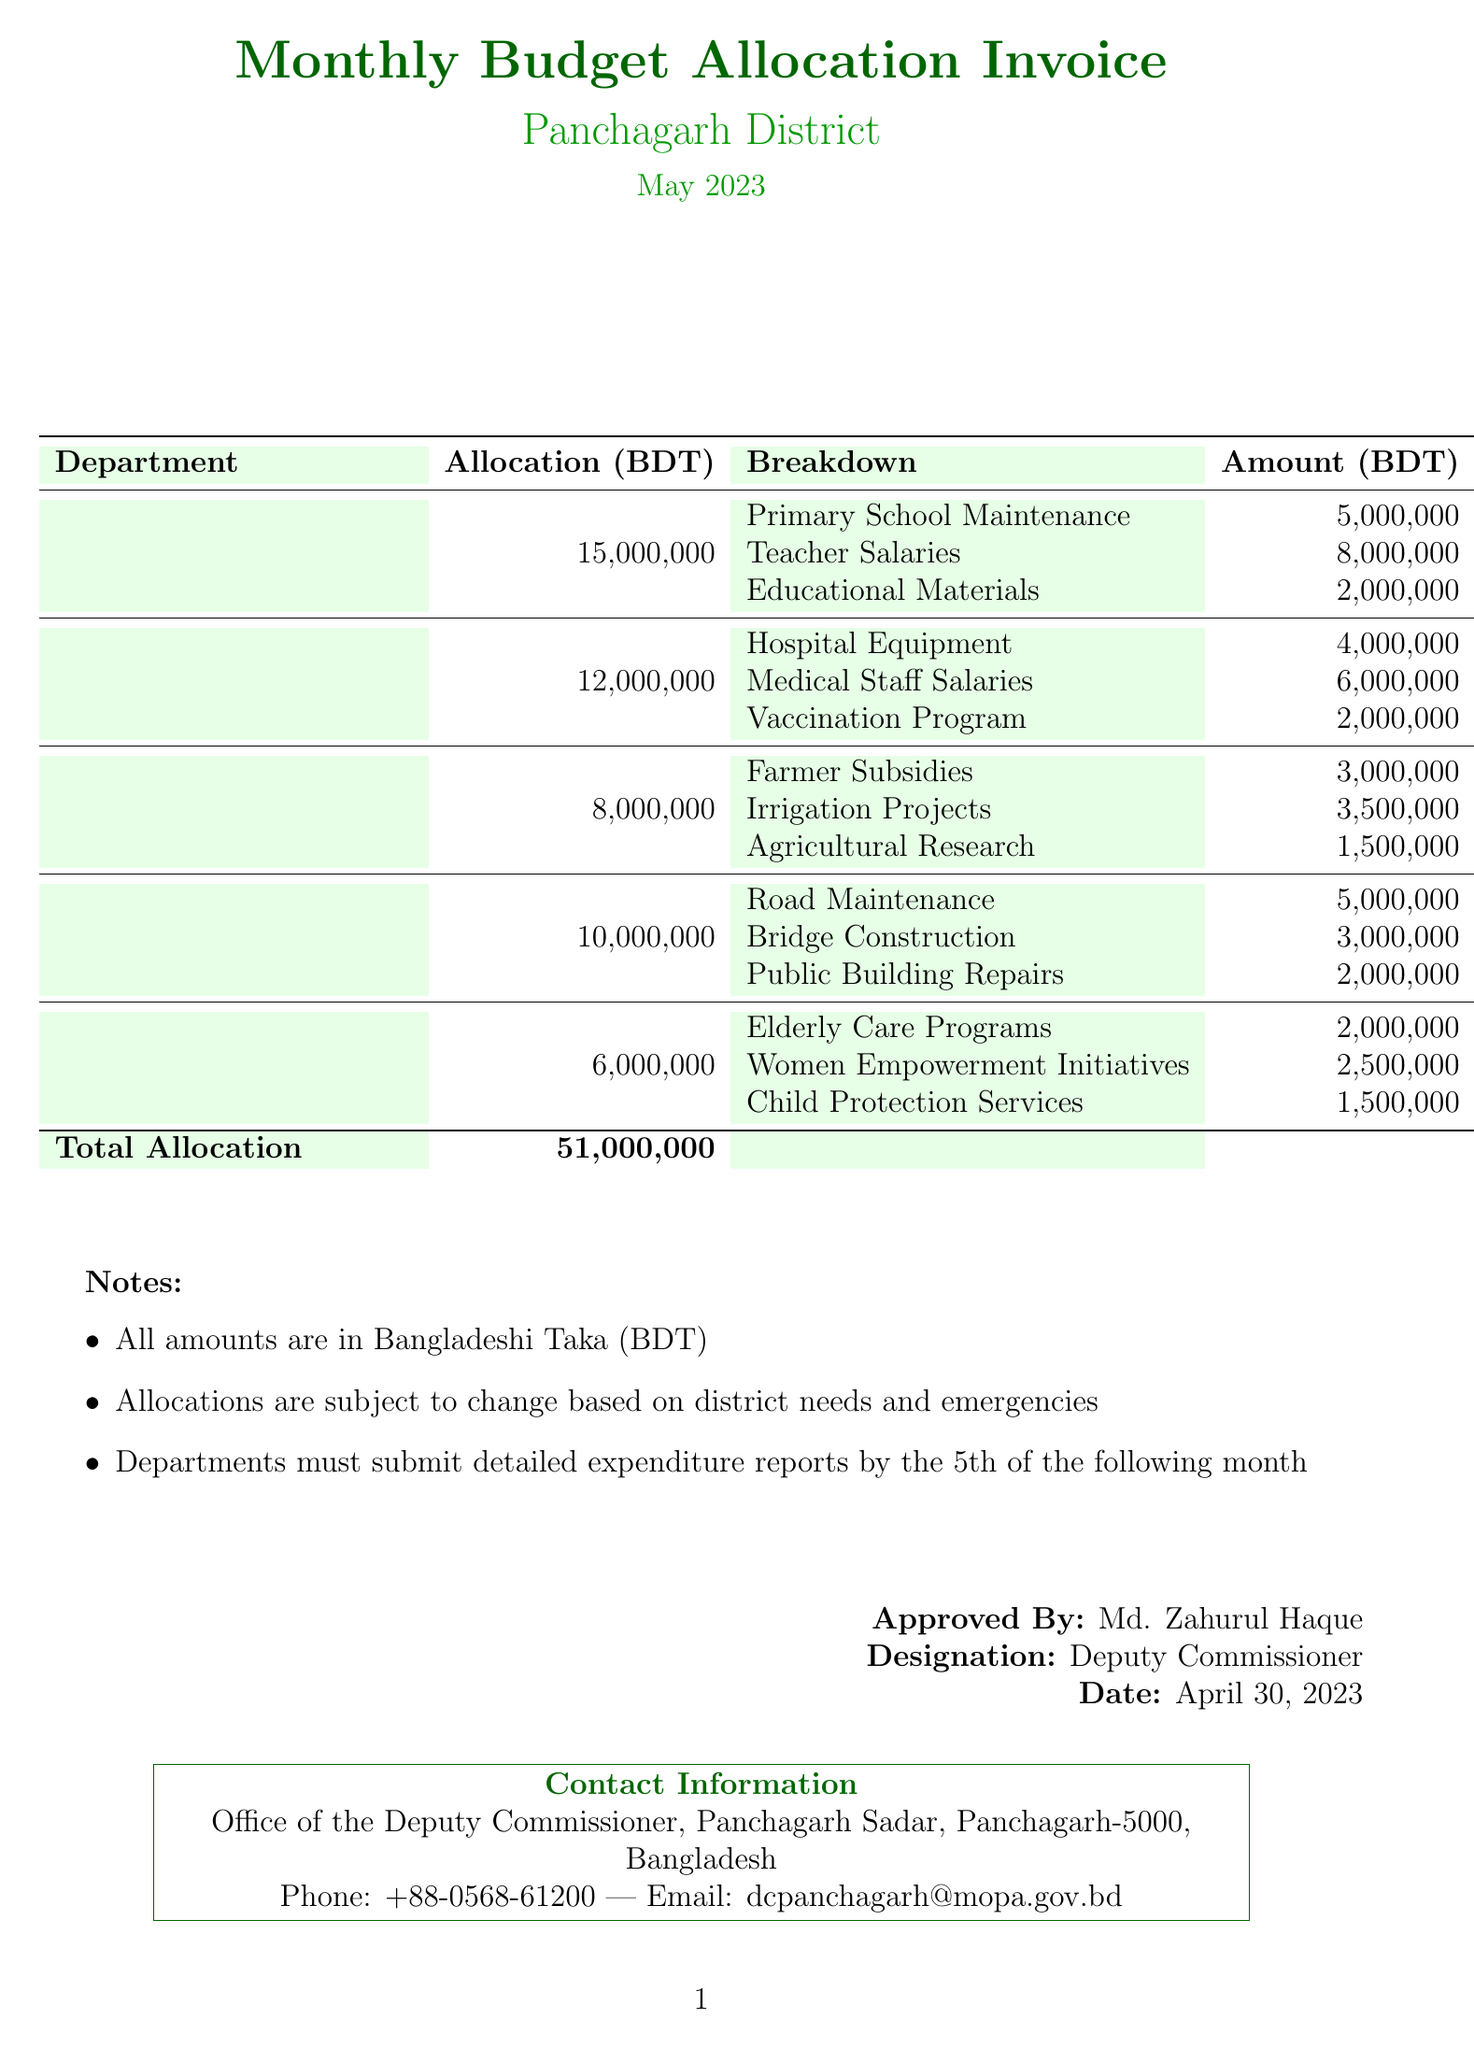What is the title of the document? The title is specified at the top of the document under the header section.
Answer: Monthly Budget Allocation Invoice Who issued the invoice? The issuer of the invoice is mentioned in the document's header.
Answer: Office of the Deputy Commissioner, Panchagarh What is the total allocation mentioned in the invoice? The total allocation is provided at the bottom of the budget breakdown section.
Answer: 51,000,000 How much is allocated to the Education Department? The allocation for the Education Department is specified in the breakdown.
Answer: 15,000,000 What is the amount allocated for Medical Staff Salaries? This specific amount is listed in the breakdown for the Health Department.
Answer: 6,000,000 Who approved the budget allocation? The approver's name is provided in the approval section of the document.
Answer: Md. Zahurul Haque What is the deadline for departments to submit expenditure reports? The deadline for submission is mentioned in the notes section of the invoice.
Answer: 5th of the following month What is the phone number of the Deputy Commissioner's office? The contact information section lists the phone number.
Answer: +88-0568-61200 How much is allocated for Elderly Care Programs? This amount is found in the breakdown for the Social Welfare Department.
Answer: 2,000,000 